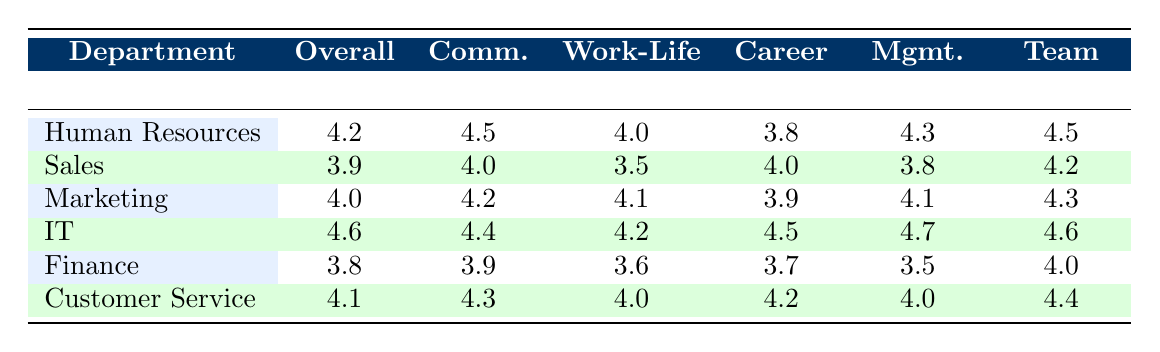What is the overall satisfaction score for the IT department? The overall satisfaction score for the IT department is directly listed in the table under the "Overall" column for IT, which is 4.6.
Answer: 4.6 Which department has the highest management support rating? The management support rating for each department is listed, and the highest value is for the IT department with a score of 4.7.
Answer: IT What is the average work-life balance rating for all departments? To find the average work-life balance rating, add the ratings together: 4.0 (HR) + 3.5 (Sales) + 4.1 (Marketing) + 4.2 (IT) + 3.6 (Finance) + 4.0 (Customer Service) = 23.4. There are 6 departments, so divide by 6: 23.4 / 6 = 3.9.
Answer: 3.9 Is the overall satisfaction score for Finance greater than that of Marketing? The overall satisfaction score for Finance is 3.8 and for Marketing is 4.0. Since 3.8 is less than 4.0, the statement is false.
Answer: No Which two departments have a team culture rating above 4.4? The team culture ratings are compared; IT has 4.6, and Customer Service has 4.4, both above 4.4. Therefore, the departments are IT and Customer Service.
Answer: IT, Customer Service What is the difference in overall satisfaction between Human Resources and Sales? The overall satisfaction for Human Resources is 4.2, and for Sales, it is 3.9. The difference is calculated as 4.2 - 3.9 = 0.3.
Answer: 0.3 Does the Marketing department have a work-life balance rating lower than 4.0? The work-life balance rating for Marketing is 4.1, which is higher than 4.0, therefore the statement is false.
Answer: No Which department has the lowest career development rating? The department with the lowest career development rating can be identified by comparing all values; Finance has a rating of 3.7, which is the lowest.
Answer: Finance 